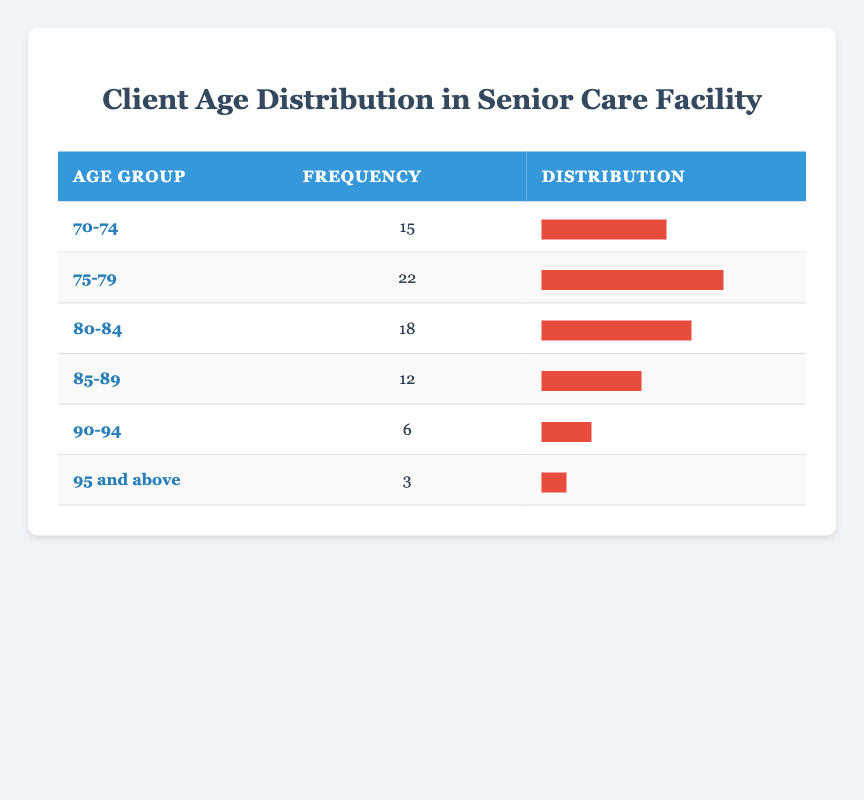What is the frequency of clients aged 75-79? In the table, the frequency column shows that for the age group 75-79, the frequency is 22.
Answer: 22 Which age group has the least number of clients? Looking at the frequency column, the age group 95 and above has the lowest frequency with 3 clients.
Answer: 95 and above What is the total number of clients across all age groups? To find the total, we sum the frequencies: 15 + 22 + 18 + 12 + 6 + 3 = 76.
Answer: 76 Is there an age group with a frequency greater than 20? Checking the frequencies, the age group 75-79 has 22 clients, which is greater than 20.
Answer: Yes What percentage of clients are in the age group 80-84? The frequency for 80-84 is 18. We divide this by the total number of clients (76) and multiply by 100: (18/76) * 100 ≈ 23.68%.
Answer: 23.68% If we combine the clients aged 90 and above, how many clients are there? We add the frequencies for the age groups 90-94 (6) and 95 and above (3): 6 + 3 = 9.
Answer: 9 What is the average frequency of clients in the age groups? First, we sum all frequencies: 15 + 22 + 18 + 12 + 6 + 3 = 76. There are 6 age groups, so the average is 76/6 ≈ 12.67.
Answer: 12.67 Which age group has the highest frequency, and what is that frequency? The highest frequency is found in the age group 75-79, where the frequency is 22.
Answer: 75-79, 22 How many clients are aged 85 and older? To find this, we sum the frequencies of the age groups 85-89 (12), 90-94 (6), and 95 and above (3): 12 + 6 + 3 = 21.
Answer: 21 